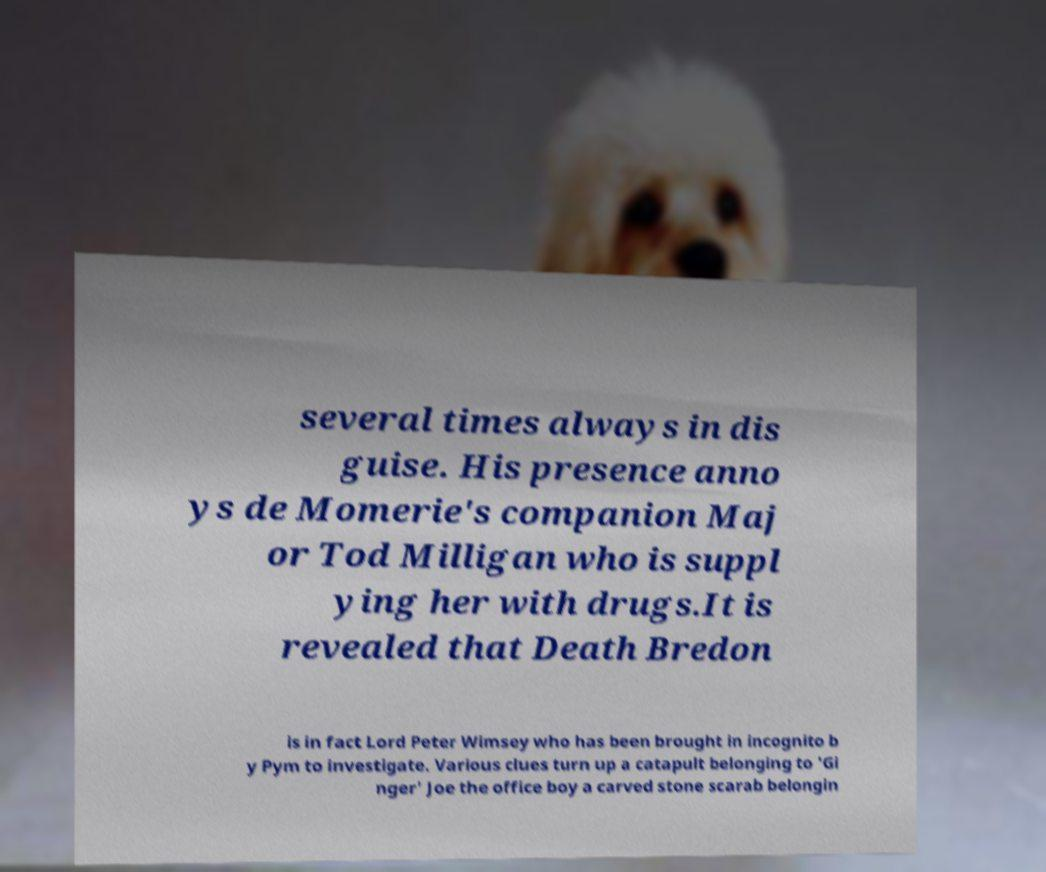Could you extract and type out the text from this image? several times always in dis guise. His presence anno ys de Momerie's companion Maj or Tod Milligan who is suppl ying her with drugs.It is revealed that Death Bredon is in fact Lord Peter Wimsey who has been brought in incognito b y Pym to investigate. Various clues turn up a catapult belonging to 'Gi nger' Joe the office boy a carved stone scarab belongin 